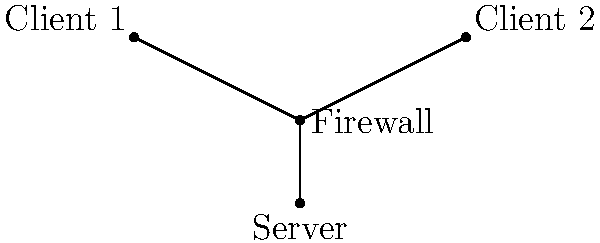In the network diagram above, which type of attack is most likely to exploit vulnerabilities in the application layer and potentially compromise the server's database? To answer this question, let's analyze the different types of attacks shown in the diagram:

1. DDoS (Distributed Denial of Service):
   - Targets: Usually affects the network infrastructure or server resources.
   - Layer: Typically operates at the network or transport layer.
   - Goal: Overwhelm the target with traffic, making it unavailable to legitimate users.

2. Man-in-the-Middle:
   - Targets: Communication between clients and the server.
   - Layer: Can occur at various layers, but often targets the session or presentation layer.
   - Goal: Intercept and potentially alter communication between two parties.

3. SQL Injection:
   - Targets: Database-driven web applications.
   - Layer: Operates at the application layer.
   - Goal: Manipulate or retrieve data from the database by injecting malicious SQL code.

Considering the question asks about exploiting vulnerabilities in the application layer and potentially compromising the server's database, the SQL Injection attack is the most relevant. This type of attack specifically targets web applications and can directly interact with the database if successful.

As a JavaScript developer interested in robotics, you would be familiar with web applications and the importance of sanitizing user inputs to prevent such attacks. In robotics, similar principles apply when dealing with command inputs or API interactions to ensure system security.
Answer: SQL Injection 